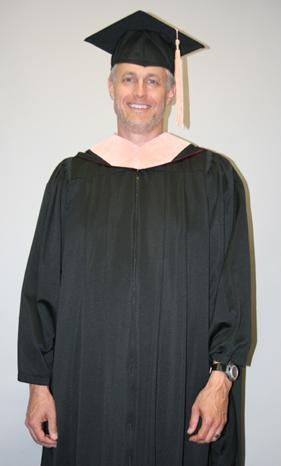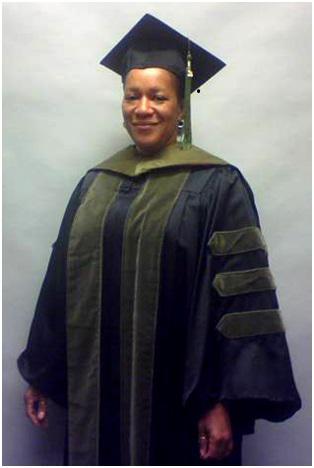The first image is the image on the left, the second image is the image on the right. Given the left and right images, does the statement "There are two graduates in the pair of images." hold true? Answer yes or no. Yes. The first image is the image on the left, the second image is the image on the right. Analyze the images presented: Is the assertion "One of the images has one man and at least 3 women." valid? Answer yes or no. No. 